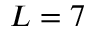<formula> <loc_0><loc_0><loc_500><loc_500>L = 7</formula> 